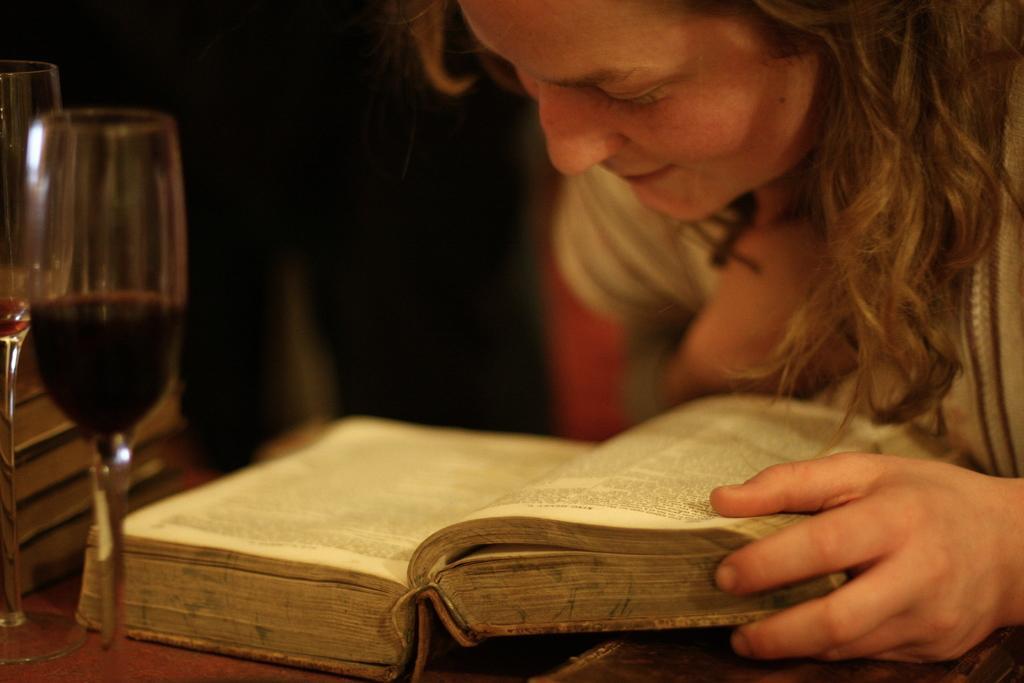In one or two sentences, can you explain what this image depicts? There is a lady holding a book. And the book is on a table. Also there are glasses. 